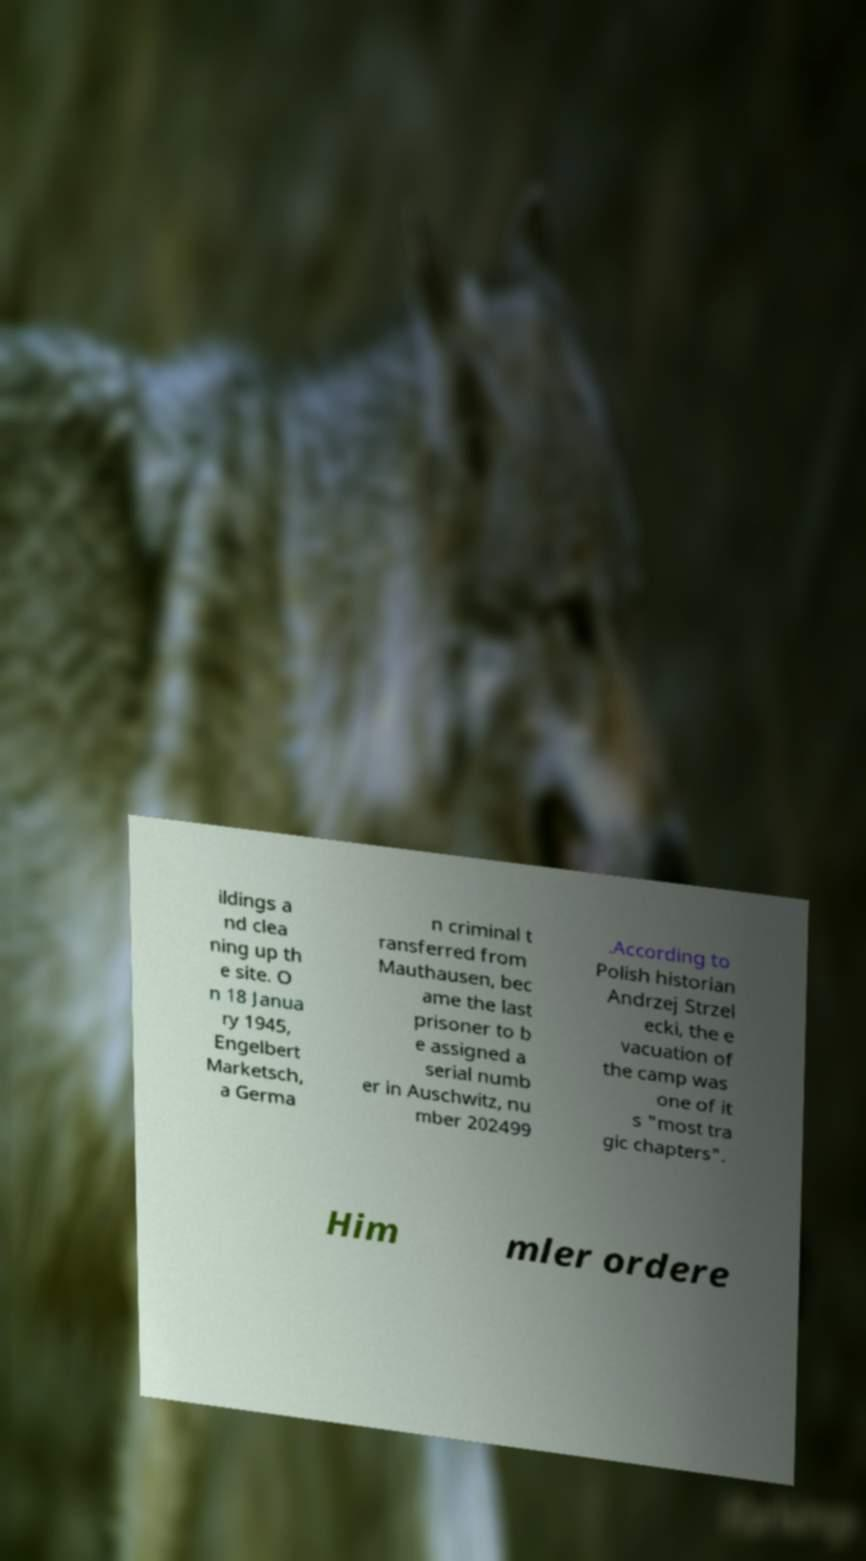Could you extract and type out the text from this image? ildings a nd clea ning up th e site. O n 18 Janua ry 1945, Engelbert Marketsch, a Germa n criminal t ransferred from Mauthausen, bec ame the last prisoner to b e assigned a serial numb er in Auschwitz, nu mber 202499 .According to Polish historian Andrzej Strzel ecki, the e vacuation of the camp was one of it s "most tra gic chapters". Him mler ordere 